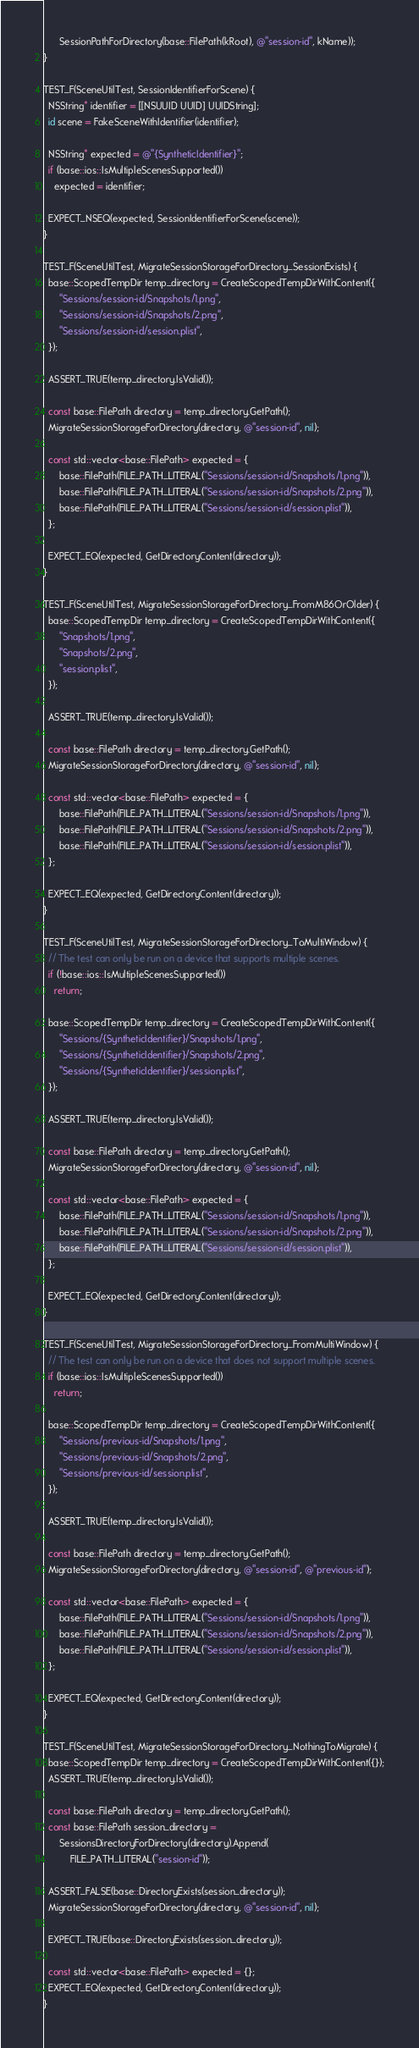<code> <loc_0><loc_0><loc_500><loc_500><_ObjectiveC_>      SessionPathForDirectory(base::FilePath(kRoot), @"session-id", kName));
}

TEST_F(SceneUtilTest, SessionIdentifierForScene) {
  NSString* identifier = [[NSUUID UUID] UUIDString];
  id scene = FakeSceneWithIdentifier(identifier);

  NSString* expected = @"{SyntheticIdentifier}";
  if (base::ios::IsMultipleScenesSupported())
    expected = identifier;

  EXPECT_NSEQ(expected, SessionIdentifierForScene(scene));
}

TEST_F(SceneUtilTest, MigrateSessionStorageForDirectory_SessionExists) {
  base::ScopedTempDir temp_directory = CreateScopedTempDirWithContent({
      "Sessions/session-id/Snapshots/1.png",
      "Sessions/session-id/Snapshots/2.png",
      "Sessions/session-id/session.plist",
  });

  ASSERT_TRUE(temp_directory.IsValid());

  const base::FilePath directory = temp_directory.GetPath();
  MigrateSessionStorageForDirectory(directory, @"session-id", nil);

  const std::vector<base::FilePath> expected = {
      base::FilePath(FILE_PATH_LITERAL("Sessions/session-id/Snapshots/1.png")),
      base::FilePath(FILE_PATH_LITERAL("Sessions/session-id/Snapshots/2.png")),
      base::FilePath(FILE_PATH_LITERAL("Sessions/session-id/session.plist")),
  };

  EXPECT_EQ(expected, GetDirectoryContent(directory));
}

TEST_F(SceneUtilTest, MigrateSessionStorageForDirectory_FromM86OrOlder) {
  base::ScopedTempDir temp_directory = CreateScopedTempDirWithContent({
      "Snapshots/1.png",
      "Snapshots/2.png",
      "session.plist",
  });

  ASSERT_TRUE(temp_directory.IsValid());

  const base::FilePath directory = temp_directory.GetPath();
  MigrateSessionStorageForDirectory(directory, @"session-id", nil);

  const std::vector<base::FilePath> expected = {
      base::FilePath(FILE_PATH_LITERAL("Sessions/session-id/Snapshots/1.png")),
      base::FilePath(FILE_PATH_LITERAL("Sessions/session-id/Snapshots/2.png")),
      base::FilePath(FILE_PATH_LITERAL("Sessions/session-id/session.plist")),
  };

  EXPECT_EQ(expected, GetDirectoryContent(directory));
}

TEST_F(SceneUtilTest, MigrateSessionStorageForDirectory_ToMultiWindow) {
  // The test can only be run on a device that supports multiple scenes.
  if (!base::ios::IsMultipleScenesSupported())
    return;

  base::ScopedTempDir temp_directory = CreateScopedTempDirWithContent({
      "Sessions/{SyntheticIdentifier}/Snapshots/1.png",
      "Sessions/{SyntheticIdentifier}/Snapshots/2.png",
      "Sessions/{SyntheticIdentifier}/session.plist",
  });

  ASSERT_TRUE(temp_directory.IsValid());

  const base::FilePath directory = temp_directory.GetPath();
  MigrateSessionStorageForDirectory(directory, @"session-id", nil);

  const std::vector<base::FilePath> expected = {
      base::FilePath(FILE_PATH_LITERAL("Sessions/session-id/Snapshots/1.png")),
      base::FilePath(FILE_PATH_LITERAL("Sessions/session-id/Snapshots/2.png")),
      base::FilePath(FILE_PATH_LITERAL("Sessions/session-id/session.plist")),
  };

  EXPECT_EQ(expected, GetDirectoryContent(directory));
}

TEST_F(SceneUtilTest, MigrateSessionStorageForDirectory_FromMultiWindow) {
  // The test can only be run on a device that does not support multiple scenes.
  if (base::ios::IsMultipleScenesSupported())
    return;

  base::ScopedTempDir temp_directory = CreateScopedTempDirWithContent({
      "Sessions/previous-id/Snapshots/1.png",
      "Sessions/previous-id/Snapshots/2.png",
      "Sessions/previous-id/session.plist",
  });

  ASSERT_TRUE(temp_directory.IsValid());

  const base::FilePath directory = temp_directory.GetPath();
  MigrateSessionStorageForDirectory(directory, @"session-id", @"previous-id");

  const std::vector<base::FilePath> expected = {
      base::FilePath(FILE_PATH_LITERAL("Sessions/session-id/Snapshots/1.png")),
      base::FilePath(FILE_PATH_LITERAL("Sessions/session-id/Snapshots/2.png")),
      base::FilePath(FILE_PATH_LITERAL("Sessions/session-id/session.plist")),
  };

  EXPECT_EQ(expected, GetDirectoryContent(directory));
}

TEST_F(SceneUtilTest, MigrateSessionStorageForDirectory_NothingToMigrate) {
  base::ScopedTempDir temp_directory = CreateScopedTempDirWithContent({});
  ASSERT_TRUE(temp_directory.IsValid());

  const base::FilePath directory = temp_directory.GetPath();
  const base::FilePath session_directory =
      SessionsDirectoryForDirectory(directory).Append(
          FILE_PATH_LITERAL("session-id"));

  ASSERT_FALSE(base::DirectoryExists(session_directory));
  MigrateSessionStorageForDirectory(directory, @"session-id", nil);

  EXPECT_TRUE(base::DirectoryExists(session_directory));

  const std::vector<base::FilePath> expected = {};
  EXPECT_EQ(expected, GetDirectoryContent(directory));
}
</code> 